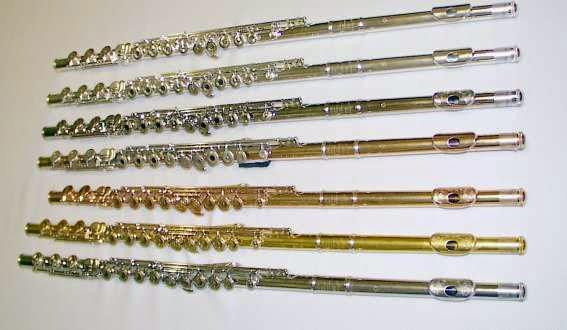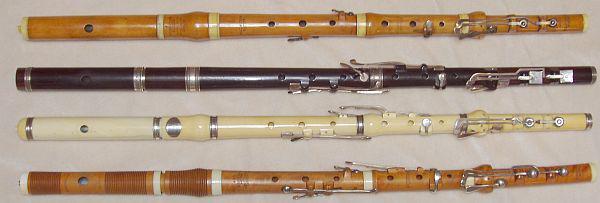The first image is the image on the left, the second image is the image on the right. Given the left and right images, does the statement "All the flutes are assembled." hold true? Answer yes or no. Yes. The first image is the image on the left, the second image is the image on the right. For the images displayed, is the sentence "One image shows a shiny pale gold flute in parts inside an open case." factually correct? Answer yes or no. No. 